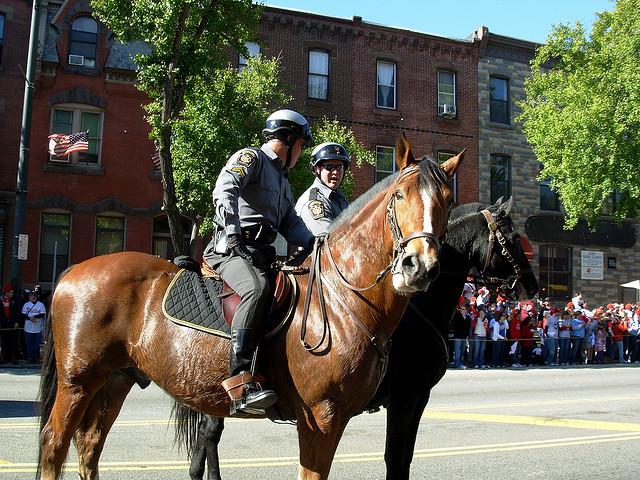How many horses are here?
Be succinct. 2. What kind of authority is on the horse?
Keep it brief. Police. Why are the people gathered?
Quick response, please. Parade. 